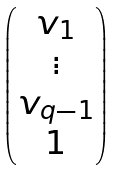<formula> <loc_0><loc_0><loc_500><loc_500>\begin{pmatrix} v _ { 1 } \\ \vdots \\ v _ { q - 1 } \\ 1 \end{pmatrix}</formula> 